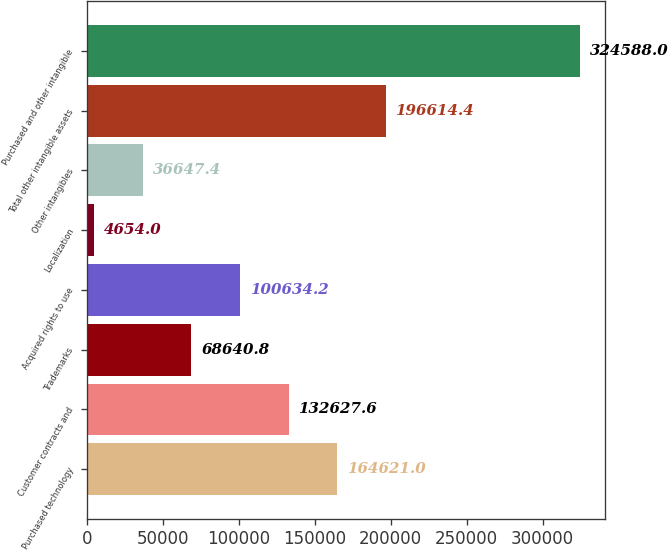<chart> <loc_0><loc_0><loc_500><loc_500><bar_chart><fcel>Purchased technology<fcel>Customer contracts and<fcel>Trademarks<fcel>Acquired rights to use<fcel>Localization<fcel>Other intangibles<fcel>Total other intangible assets<fcel>Purchased and other intangible<nl><fcel>164621<fcel>132628<fcel>68640.8<fcel>100634<fcel>4654<fcel>36647.4<fcel>196614<fcel>324588<nl></chart> 